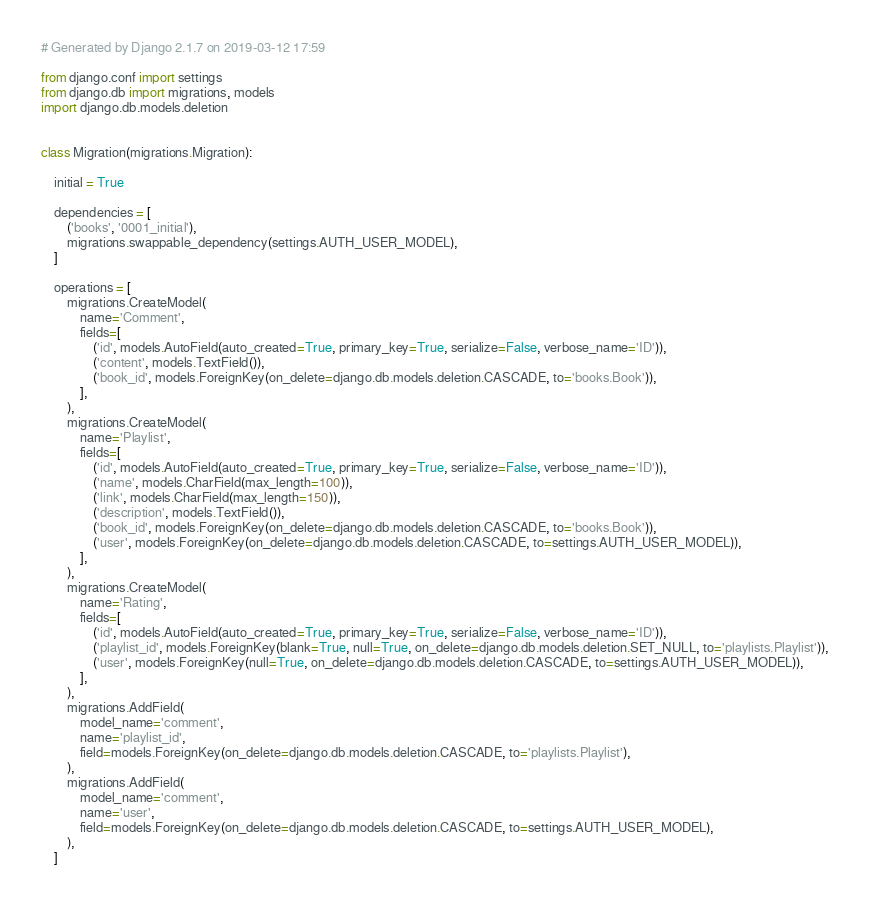<code> <loc_0><loc_0><loc_500><loc_500><_Python_># Generated by Django 2.1.7 on 2019-03-12 17:59

from django.conf import settings
from django.db import migrations, models
import django.db.models.deletion


class Migration(migrations.Migration):

    initial = True

    dependencies = [
        ('books', '0001_initial'),
        migrations.swappable_dependency(settings.AUTH_USER_MODEL),
    ]

    operations = [
        migrations.CreateModel(
            name='Comment',
            fields=[
                ('id', models.AutoField(auto_created=True, primary_key=True, serialize=False, verbose_name='ID')),
                ('content', models.TextField()),
                ('book_id', models.ForeignKey(on_delete=django.db.models.deletion.CASCADE, to='books.Book')),
            ],
        ),
        migrations.CreateModel(
            name='Playlist',
            fields=[
                ('id', models.AutoField(auto_created=True, primary_key=True, serialize=False, verbose_name='ID')),
                ('name', models.CharField(max_length=100)),
                ('link', models.CharField(max_length=150)),
                ('description', models.TextField()),
                ('book_id', models.ForeignKey(on_delete=django.db.models.deletion.CASCADE, to='books.Book')),
                ('user', models.ForeignKey(on_delete=django.db.models.deletion.CASCADE, to=settings.AUTH_USER_MODEL)),
            ],
        ),
        migrations.CreateModel(
            name='Rating',
            fields=[
                ('id', models.AutoField(auto_created=True, primary_key=True, serialize=False, verbose_name='ID')),
                ('playlist_id', models.ForeignKey(blank=True, null=True, on_delete=django.db.models.deletion.SET_NULL, to='playlists.Playlist')),
                ('user', models.ForeignKey(null=True, on_delete=django.db.models.deletion.CASCADE, to=settings.AUTH_USER_MODEL)),
            ],
        ),
        migrations.AddField(
            model_name='comment',
            name='playlist_id',
            field=models.ForeignKey(on_delete=django.db.models.deletion.CASCADE, to='playlists.Playlist'),
        ),
        migrations.AddField(
            model_name='comment',
            name='user',
            field=models.ForeignKey(on_delete=django.db.models.deletion.CASCADE, to=settings.AUTH_USER_MODEL),
        ),
    ]
</code> 